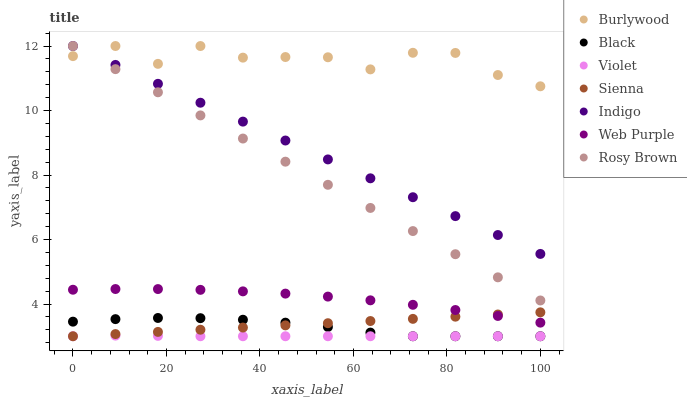Does Violet have the minimum area under the curve?
Answer yes or no. Yes. Does Burlywood have the maximum area under the curve?
Answer yes or no. Yes. Does Rosy Brown have the minimum area under the curve?
Answer yes or no. No. Does Rosy Brown have the maximum area under the curve?
Answer yes or no. No. Is Sienna the smoothest?
Answer yes or no. Yes. Is Burlywood the roughest?
Answer yes or no. Yes. Is Rosy Brown the smoothest?
Answer yes or no. No. Is Rosy Brown the roughest?
Answer yes or no. No. Does Sienna have the lowest value?
Answer yes or no. Yes. Does Rosy Brown have the lowest value?
Answer yes or no. No. Does Rosy Brown have the highest value?
Answer yes or no. Yes. Does Sienna have the highest value?
Answer yes or no. No. Is Black less than Web Purple?
Answer yes or no. Yes. Is Indigo greater than Sienna?
Answer yes or no. Yes. Does Indigo intersect Rosy Brown?
Answer yes or no. Yes. Is Indigo less than Rosy Brown?
Answer yes or no. No. Is Indigo greater than Rosy Brown?
Answer yes or no. No. Does Black intersect Web Purple?
Answer yes or no. No. 